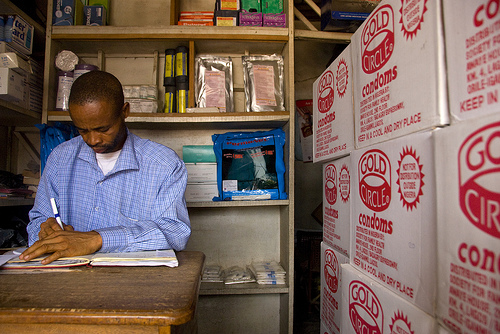<image>
Is there a book on the man? No. The book is not positioned on the man. They may be near each other, but the book is not supported by or resting on top of the man. Where is the box in relation to the man? Is it behind the man? No. The box is not behind the man. From this viewpoint, the box appears to be positioned elsewhere in the scene. 